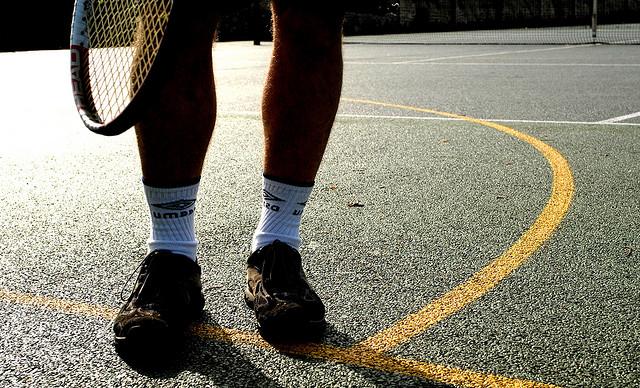What color are the man's shoes on the tennis court?
Short answer required. Black. Is the person wearing socks?
Keep it brief. Yes. What to the white lines depict?
Be succinct. Boundaries. 